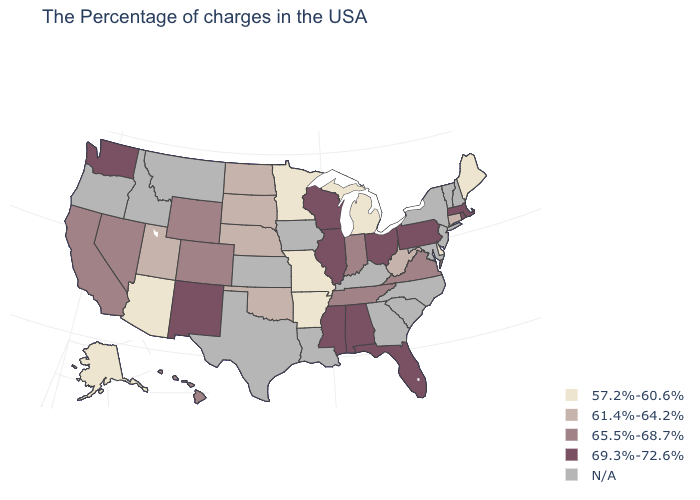Name the states that have a value in the range N/A?
Keep it brief. New Hampshire, Vermont, New York, New Jersey, Maryland, North Carolina, South Carolina, Georgia, Kentucky, Louisiana, Iowa, Kansas, Texas, Montana, Idaho, Oregon. How many symbols are there in the legend?
Concise answer only. 5. What is the value of Michigan?
Give a very brief answer. 57.2%-60.6%. Which states have the lowest value in the South?
Keep it brief. Delaware, Arkansas. Name the states that have a value in the range 61.4%-64.2%?
Be succinct. Connecticut, West Virginia, Nebraska, Oklahoma, South Dakota, North Dakota, Utah. What is the value of Missouri?
Write a very short answer. 57.2%-60.6%. Which states hav the highest value in the West?
Write a very short answer. New Mexico, Washington. What is the value of Kentucky?
Keep it brief. N/A. Name the states that have a value in the range 65.5%-68.7%?
Be succinct. Virginia, Indiana, Tennessee, Wyoming, Colorado, Nevada, California, Hawaii. Does West Virginia have the lowest value in the USA?
Be succinct. No. How many symbols are there in the legend?
Short answer required. 5. Is the legend a continuous bar?
Write a very short answer. No. What is the lowest value in the USA?
Write a very short answer. 57.2%-60.6%. Name the states that have a value in the range 69.3%-72.6%?
Answer briefly. Massachusetts, Rhode Island, Pennsylvania, Ohio, Florida, Alabama, Wisconsin, Illinois, Mississippi, New Mexico, Washington. What is the value of Wisconsin?
Answer briefly. 69.3%-72.6%. 